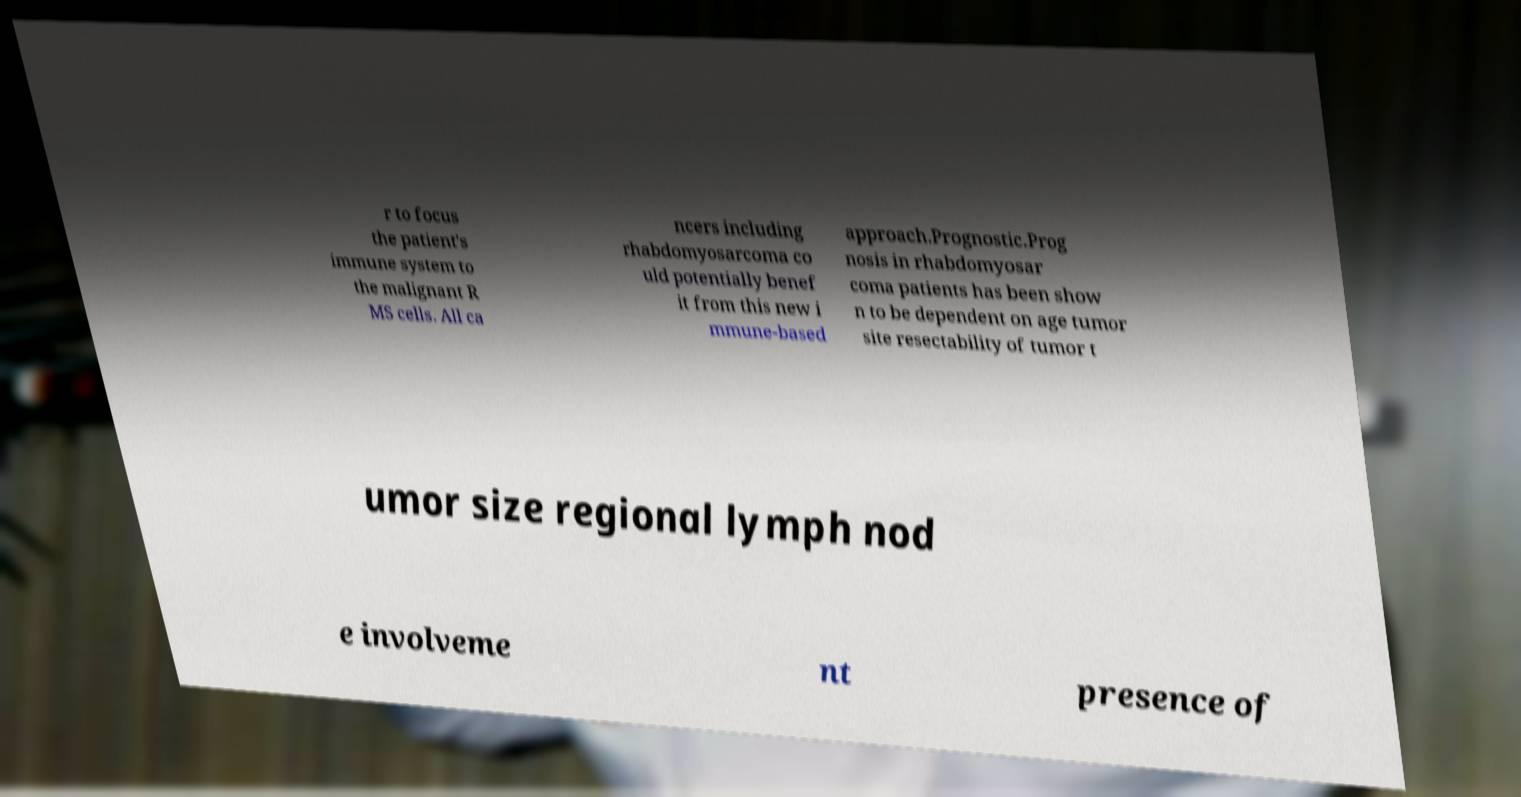Can you read and provide the text displayed in the image?This photo seems to have some interesting text. Can you extract and type it out for me? r to focus the patient's immune system to the malignant R MS cells. All ca ncers including rhabdomyosarcoma co uld potentially benef it from this new i mmune-based approach.Prognostic.Prog nosis in rhabdomyosar coma patients has been show n to be dependent on age tumor site resectability of tumor t umor size regional lymph nod e involveme nt presence of 